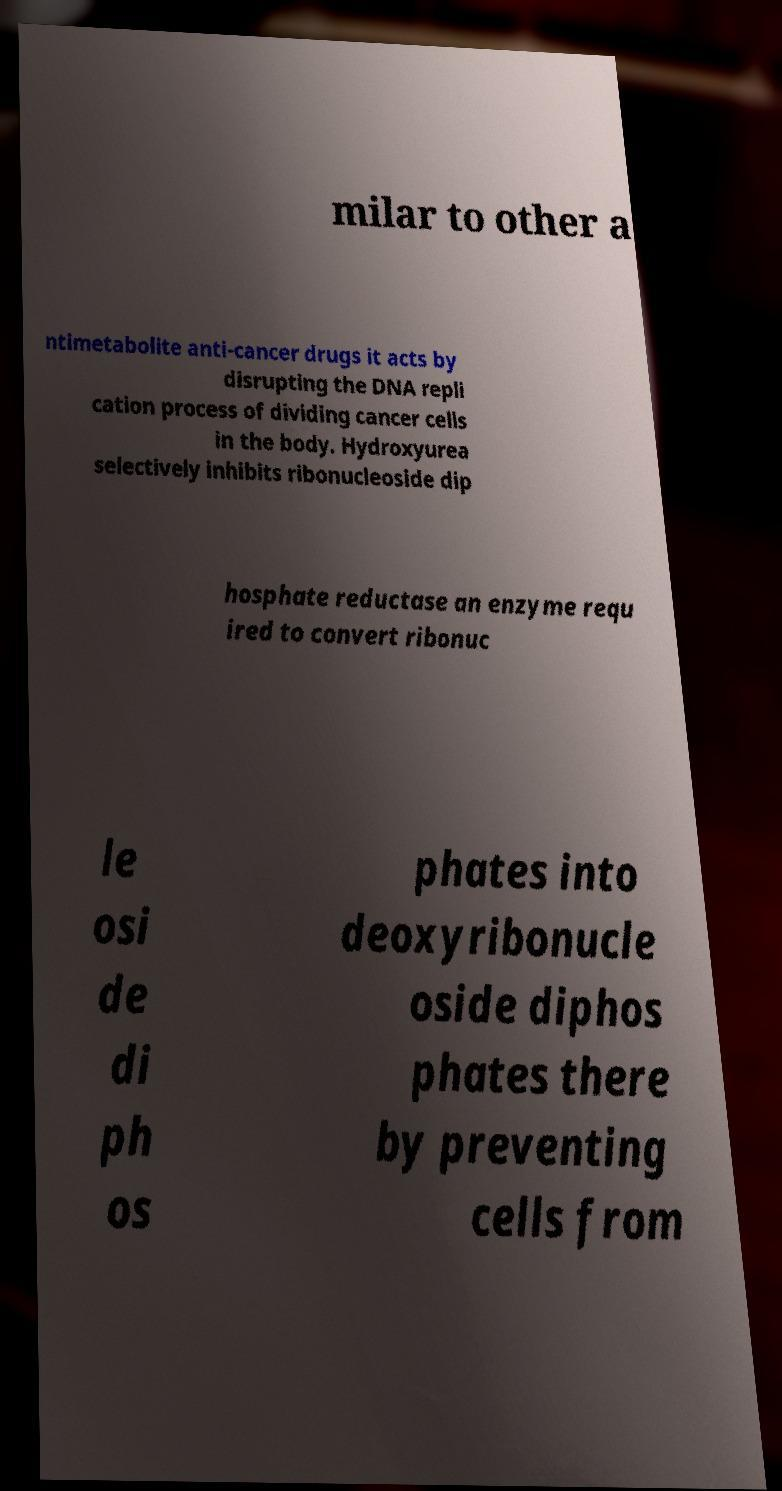For documentation purposes, I need the text within this image transcribed. Could you provide that? milar to other a ntimetabolite anti-cancer drugs it acts by disrupting the DNA repli cation process of dividing cancer cells in the body. Hydroxyurea selectively inhibits ribonucleoside dip hosphate reductase an enzyme requ ired to convert ribonuc le osi de di ph os phates into deoxyribonucle oside diphos phates there by preventing cells from 